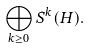Convert formula to latex. <formula><loc_0><loc_0><loc_500><loc_500>\bigoplus _ { k \geq 0 } S ^ { k } ( H ) .</formula> 